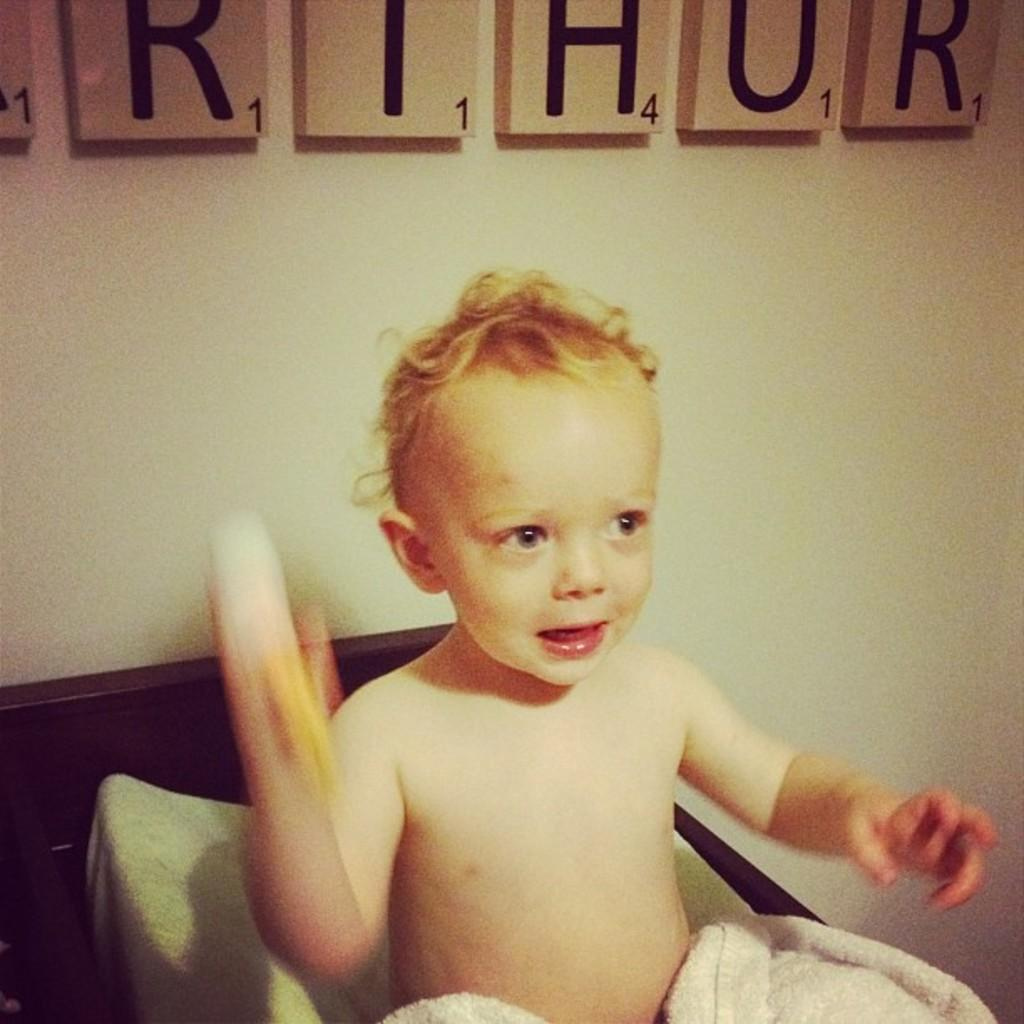What is the kid doing in the image? The kid is sitting on the bed in the image. What object can be seen in the image besides the kid and the bed? There is a cloth in the image. What can be seen on the wall in the background of the image? There are boards on the wall in the background. What is the purpose of the egg in the image? There is no egg present in the image, so it cannot serve any purpose within the context of the image. 